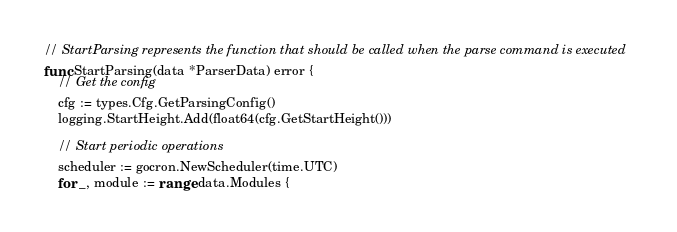<code> <loc_0><loc_0><loc_500><loc_500><_Go_>// StartParsing represents the function that should be called when the parse command is executed
func StartParsing(data *ParserData) error {
	// Get the config
	cfg := types.Cfg.GetParsingConfig()
	logging.StartHeight.Add(float64(cfg.GetStartHeight()))

	// Start periodic operations
	scheduler := gocron.NewScheduler(time.UTC)
	for _, module := range data.Modules {</code> 